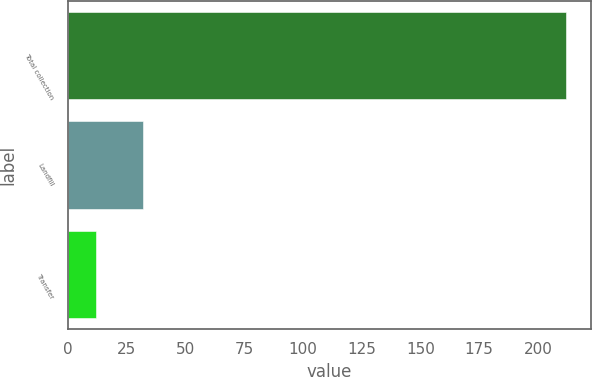<chart> <loc_0><loc_0><loc_500><loc_500><bar_chart><fcel>Total collection<fcel>Landfill<fcel>Transfer<nl><fcel>212<fcel>32<fcel>12<nl></chart> 